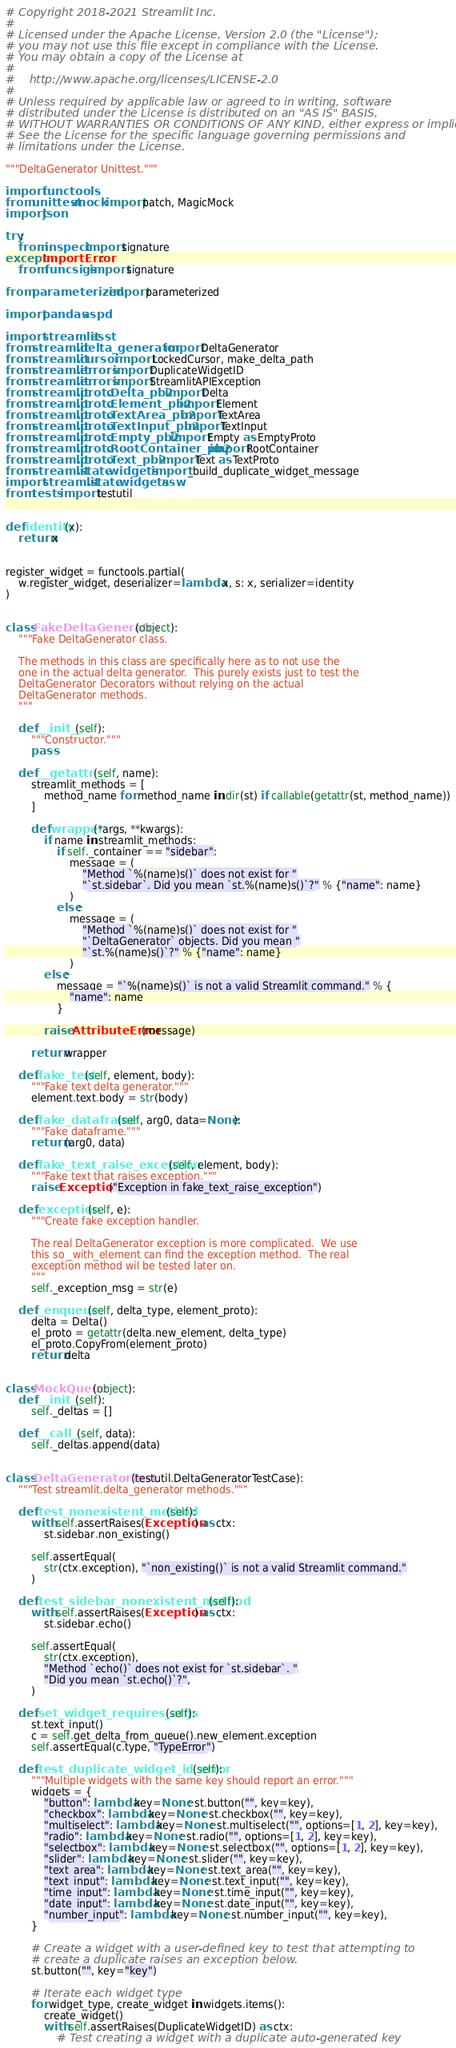Convert code to text. <code><loc_0><loc_0><loc_500><loc_500><_Python_># Copyright 2018-2021 Streamlit Inc.
#
# Licensed under the Apache License, Version 2.0 (the "License");
# you may not use this file except in compliance with the License.
# You may obtain a copy of the License at
#
#    http://www.apache.org/licenses/LICENSE-2.0
#
# Unless required by applicable law or agreed to in writing, software
# distributed under the License is distributed on an "AS IS" BASIS,
# WITHOUT WARRANTIES OR CONDITIONS OF ANY KIND, either express or implied.
# See the License for the specific language governing permissions and
# limitations under the License.

"""DeltaGenerator Unittest."""

import functools
from unittest.mock import patch, MagicMock
import json

try:
    from inspect import signature
except ImportError:
    from funcsigs import signature

from parameterized import parameterized

import pandas as pd

import streamlit as st
from streamlit.delta_generator import DeltaGenerator
from streamlit.cursor import LockedCursor, make_delta_path
from streamlit.errors import DuplicateWidgetID
from streamlit.errors import StreamlitAPIException
from streamlit.proto.Delta_pb2 import Delta
from streamlit.proto.Element_pb2 import Element
from streamlit.proto.TextArea_pb2 import TextArea
from streamlit.proto.TextInput_pb2 import TextInput
from streamlit.proto.Empty_pb2 import Empty as EmptyProto
from streamlit.proto.RootContainer_pb2 import RootContainer
from streamlit.proto.Text_pb2 import Text as TextProto
from streamlit.state.widgets import _build_duplicate_widget_message
import streamlit.state.widgets as w
from tests import testutil


def identity(x):
    return x


register_widget = functools.partial(
    w.register_widget, deserializer=lambda x, s: x, serializer=identity
)


class FakeDeltaGenerator(object):
    """Fake DeltaGenerator class.

    The methods in this class are specifically here as to not use the
    one in the actual delta generator.  This purely exists just to test the
    DeltaGenerator Decorators without relying on the actual
    DeltaGenerator methods.
    """

    def __init__(self):
        """Constructor."""
        pass

    def __getattr__(self, name):
        streamlit_methods = [
            method_name for method_name in dir(st) if callable(getattr(st, method_name))
        ]

        def wrapper(*args, **kwargs):
            if name in streamlit_methods:
                if self._container == "sidebar":
                    message = (
                        "Method `%(name)s()` does not exist for "
                        "`st.sidebar`. Did you mean `st.%(name)s()`?" % {"name": name}
                    )
                else:
                    message = (
                        "Method `%(name)s()` does not exist for "
                        "`DeltaGenerator` objects. Did you mean "
                        "`st.%(name)s()`?" % {"name": name}
                    )
            else:
                message = "`%(name)s()` is not a valid Streamlit command." % {
                    "name": name
                }

            raise AttributeError(message)

        return wrapper

    def fake_text(self, element, body):
        """Fake text delta generator."""
        element.text.body = str(body)

    def fake_dataframe(self, arg0, data=None):
        """Fake dataframe."""
        return (arg0, data)

    def fake_text_raise_exception(self, element, body):
        """Fake text that raises exception."""
        raise Exception("Exception in fake_text_raise_exception")

    def exception(self, e):
        """Create fake exception handler.

        The real DeltaGenerator exception is more complicated.  We use
        this so _with_element can find the exception method.  The real
        exception method wil be tested later on.
        """
        self._exception_msg = str(e)

    def _enqueue(self, delta_type, element_proto):
        delta = Delta()
        el_proto = getattr(delta.new_element, delta_type)
        el_proto.CopyFrom(element_proto)
        return delta


class MockQueue(object):
    def __init__(self):
        self._deltas = []

    def __call__(self, data):
        self._deltas.append(data)


class DeltaGeneratorTest(testutil.DeltaGeneratorTestCase):
    """Test streamlit.delta_generator methods."""

    def test_nonexistent_method(self):
        with self.assertRaises(Exception) as ctx:
            st.sidebar.non_existing()

        self.assertEqual(
            str(ctx.exception), "`non_existing()` is not a valid Streamlit command."
        )

    def test_sidebar_nonexistent_method(self):
        with self.assertRaises(Exception) as ctx:
            st.sidebar.echo()

        self.assertEqual(
            str(ctx.exception),
            "Method `echo()` does not exist for `st.sidebar`. "
            "Did you mean `st.echo()`?",
        )

    def set_widget_requires_args(self):
        st.text_input()
        c = self.get_delta_from_queue().new_element.exception
        self.assertEqual(c.type, "TypeError")

    def test_duplicate_widget_id_error(self):
        """Multiple widgets with the same key should report an error."""
        widgets = {
            "button": lambda key=None: st.button("", key=key),
            "checkbox": lambda key=None: st.checkbox("", key=key),
            "multiselect": lambda key=None: st.multiselect("", options=[1, 2], key=key),
            "radio": lambda key=None: st.radio("", options=[1, 2], key=key),
            "selectbox": lambda key=None: st.selectbox("", options=[1, 2], key=key),
            "slider": lambda key=None: st.slider("", key=key),
            "text_area": lambda key=None: st.text_area("", key=key),
            "text_input": lambda key=None: st.text_input("", key=key),
            "time_input": lambda key=None: st.time_input("", key=key),
            "date_input": lambda key=None: st.date_input("", key=key),
            "number_input": lambda key=None: st.number_input("", key=key),
        }

        # Create a widget with a user-defined key to test that attempting to
        # create a duplicate raises an exception below.
        st.button("", key="key")

        # Iterate each widget type
        for widget_type, create_widget in widgets.items():
            create_widget()
            with self.assertRaises(DuplicateWidgetID) as ctx:
                # Test creating a widget with a duplicate auto-generated key</code> 